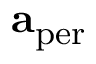Convert formula to latex. <formula><loc_0><loc_0><loc_500><loc_500>a _ { p e r }</formula> 